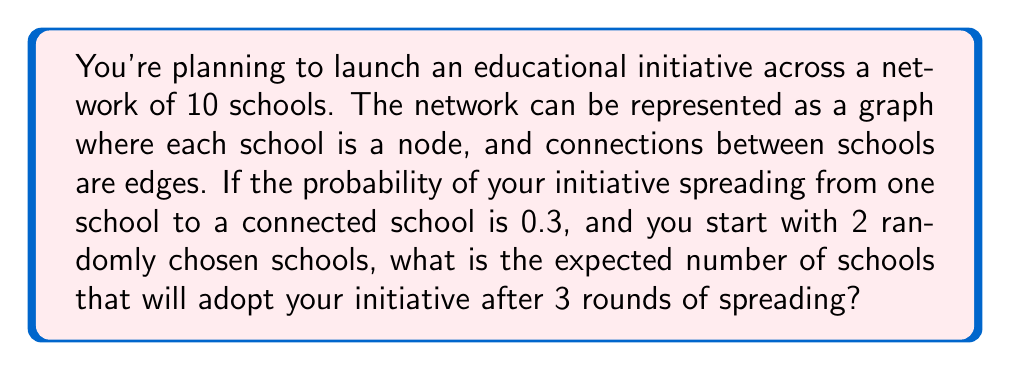What is the answer to this math problem? Let's approach this step-by-step:

1) First, we need to understand the concept of expected value in a network spreading model. The expected number of schools adopting the initiative can be calculated using the formula:

   $$E(X) = n(1-(1-p)^t)$$

   Where:
   $E(X)$ is the expected number of adopters
   $n$ is the total number of nodes (schools)
   $p$ is the probability of spreading
   $t$ is the number of time steps (rounds)

2) In this case:
   $n = 10$ (total schools)
   $p = 0.3$ (probability of spreading)
   $t = 3$ (rounds of spreading)

3) However, we start with 2 schools already adopting the initiative. So we need to adjust our calculation:

   $$E(X) = 2 + (10-2)(1-(1-0.3)^3)$$

4) Let's break down the calculation:
   
   $(1-0.3)^3 = 0.7^3 = 0.343$
   
   $1 - 0.343 = 0.657$
   
   $(10-2) * 0.657 = 8 * 0.657 = 5.256$

5) Therefore:

   $$E(X) = 2 + 5.256 = 7.256$$

6) Rounding to two decimal places:

   $$E(X) \approx 7.26$$

This means that after 3 rounds of spreading, we expect approximately 7.26 schools to have adopted the initiative.
Answer: 7.26 schools 